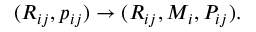<formula> <loc_0><loc_0><loc_500><loc_500>\begin{array} { r } { ( R _ { i j } , p _ { i j } ) \rightarrow ( R _ { i j } , M _ { i } , P _ { i j } ) . } \end{array}</formula> 